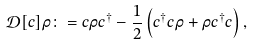<formula> <loc_0><loc_0><loc_500><loc_500>\mathcal { D } [ c ] \rho \colon = c \rho c ^ { \dagger } - \frac { 1 } { 2 } \left ( c ^ { \dagger } c \rho + \rho c ^ { \dagger } c \right ) ,</formula> 